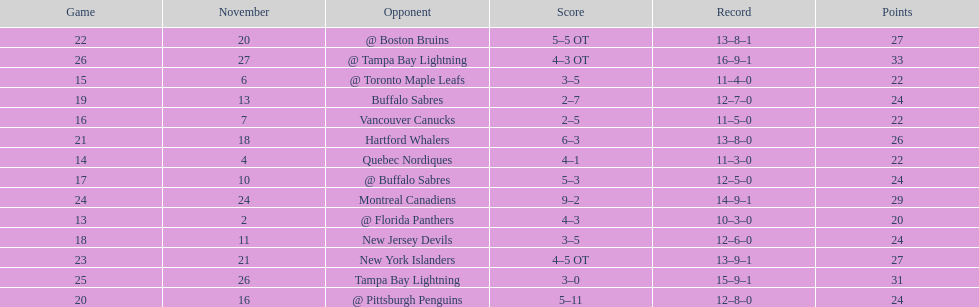Did the tampa bay lightning have the least amount of wins? Yes. Can you give me this table as a dict? {'header': ['Game', 'November', 'Opponent', 'Score', 'Record', 'Points'], 'rows': [['22', '20', '@ Boston Bruins', '5–5 OT', '13–8–1', '27'], ['26', '27', '@ Tampa Bay Lightning', '4–3 OT', '16–9–1', '33'], ['15', '6', '@ Toronto Maple Leafs', '3–5', '11–4–0', '22'], ['19', '13', 'Buffalo Sabres', '2–7', '12–7–0', '24'], ['16', '7', 'Vancouver Canucks', '2–5', '11–5–0', '22'], ['21', '18', 'Hartford Whalers', '6–3', '13–8–0', '26'], ['14', '4', 'Quebec Nordiques', '4–1', '11–3–0', '22'], ['17', '10', '@ Buffalo Sabres', '5–3', '12–5–0', '24'], ['24', '24', 'Montreal Canadiens', '9–2', '14–9–1', '29'], ['13', '2', '@ Florida Panthers', '4–3', '10–3–0', '20'], ['18', '11', 'New Jersey Devils', '3–5', '12–6–0', '24'], ['23', '21', 'New York Islanders', '4–5 OT', '13–9–1', '27'], ['25', '26', 'Tampa Bay Lightning', '3–0', '15–9–1', '31'], ['20', '16', '@ Pittsburgh Penguins', '5–11', '12–8–0', '24']]} 